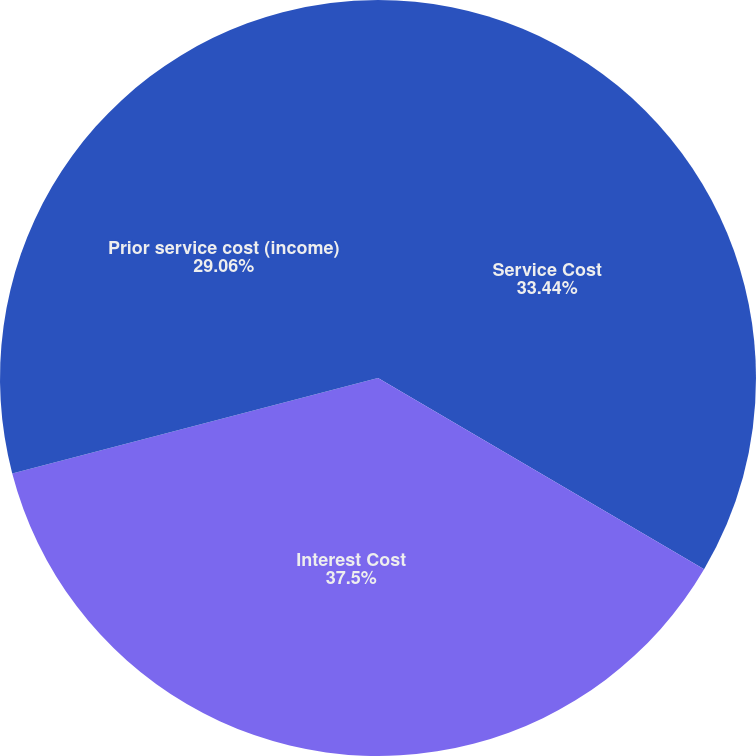Convert chart to OTSL. <chart><loc_0><loc_0><loc_500><loc_500><pie_chart><fcel>Service Cost<fcel>Interest Cost<fcel>Prior service cost (income)<nl><fcel>33.44%<fcel>37.5%<fcel>29.06%<nl></chart> 